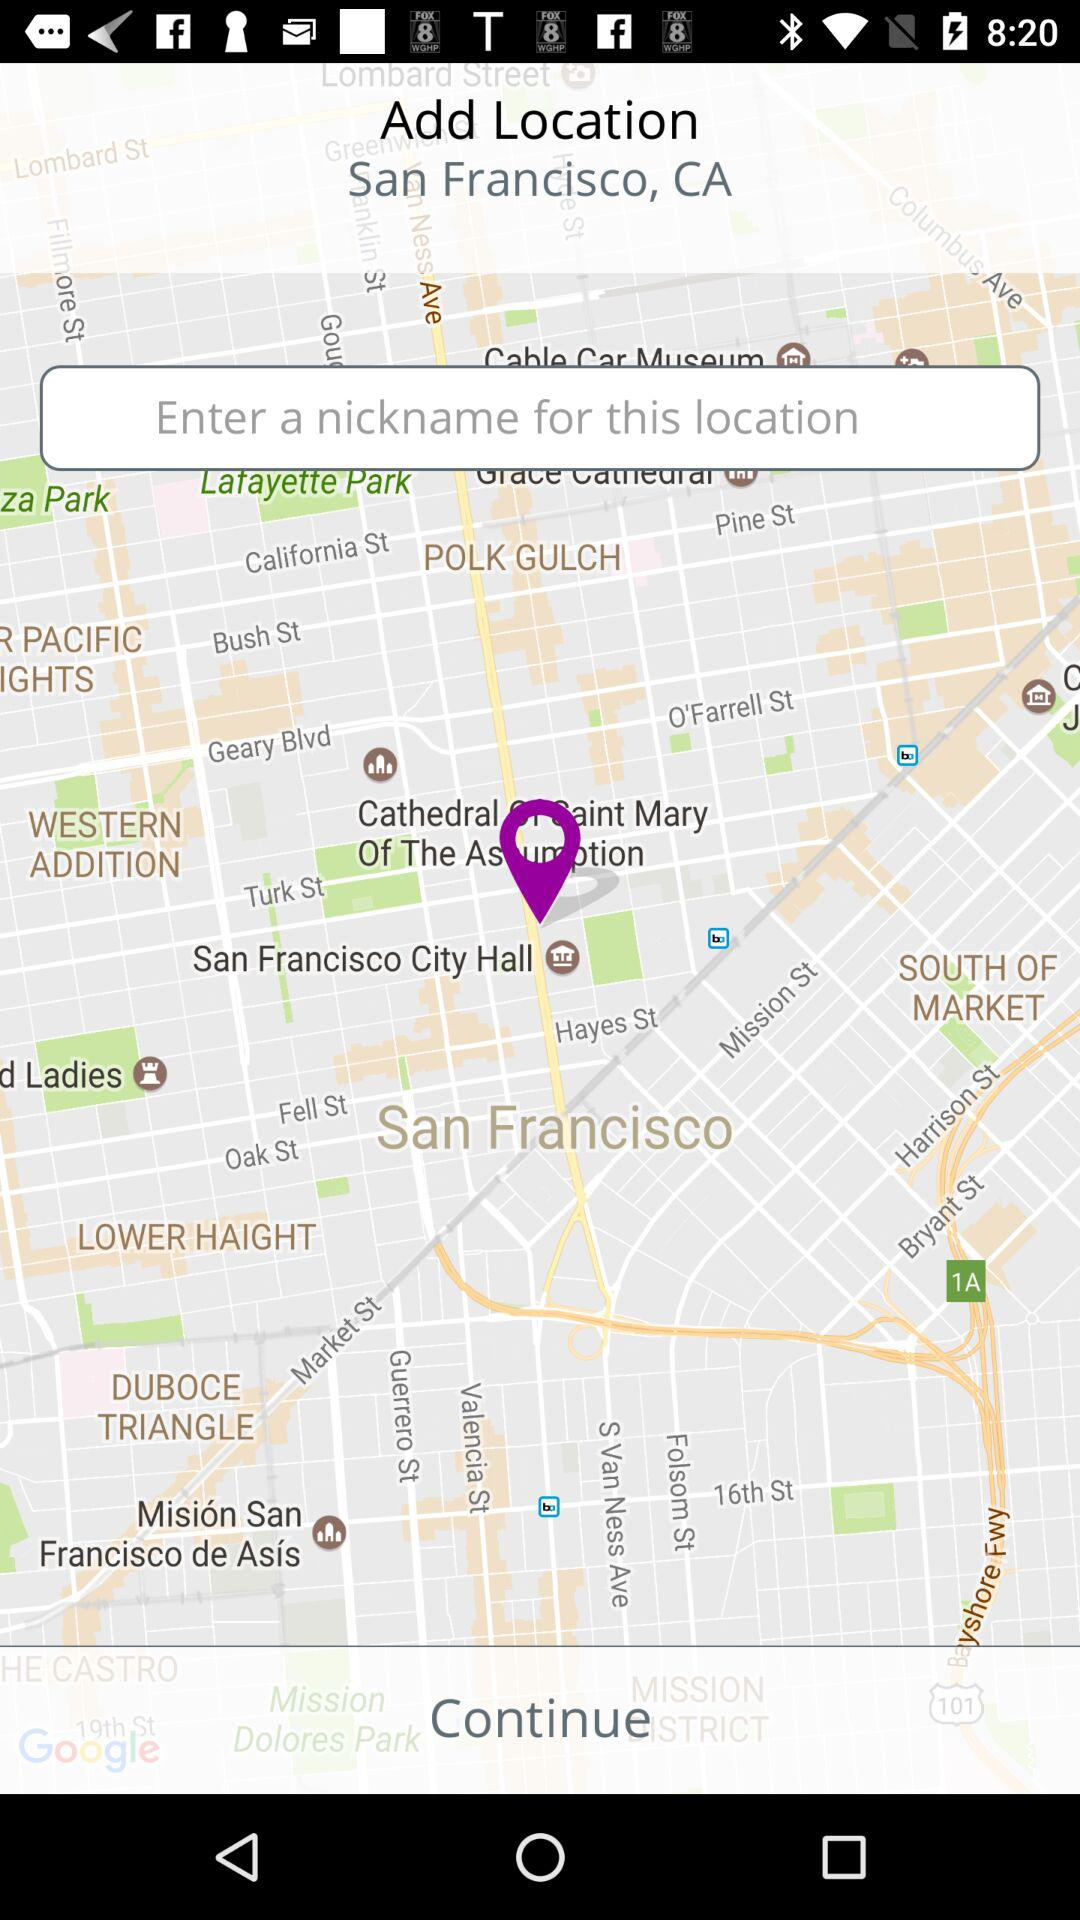Which location is selected? The selected location is San Francisco, CA. 